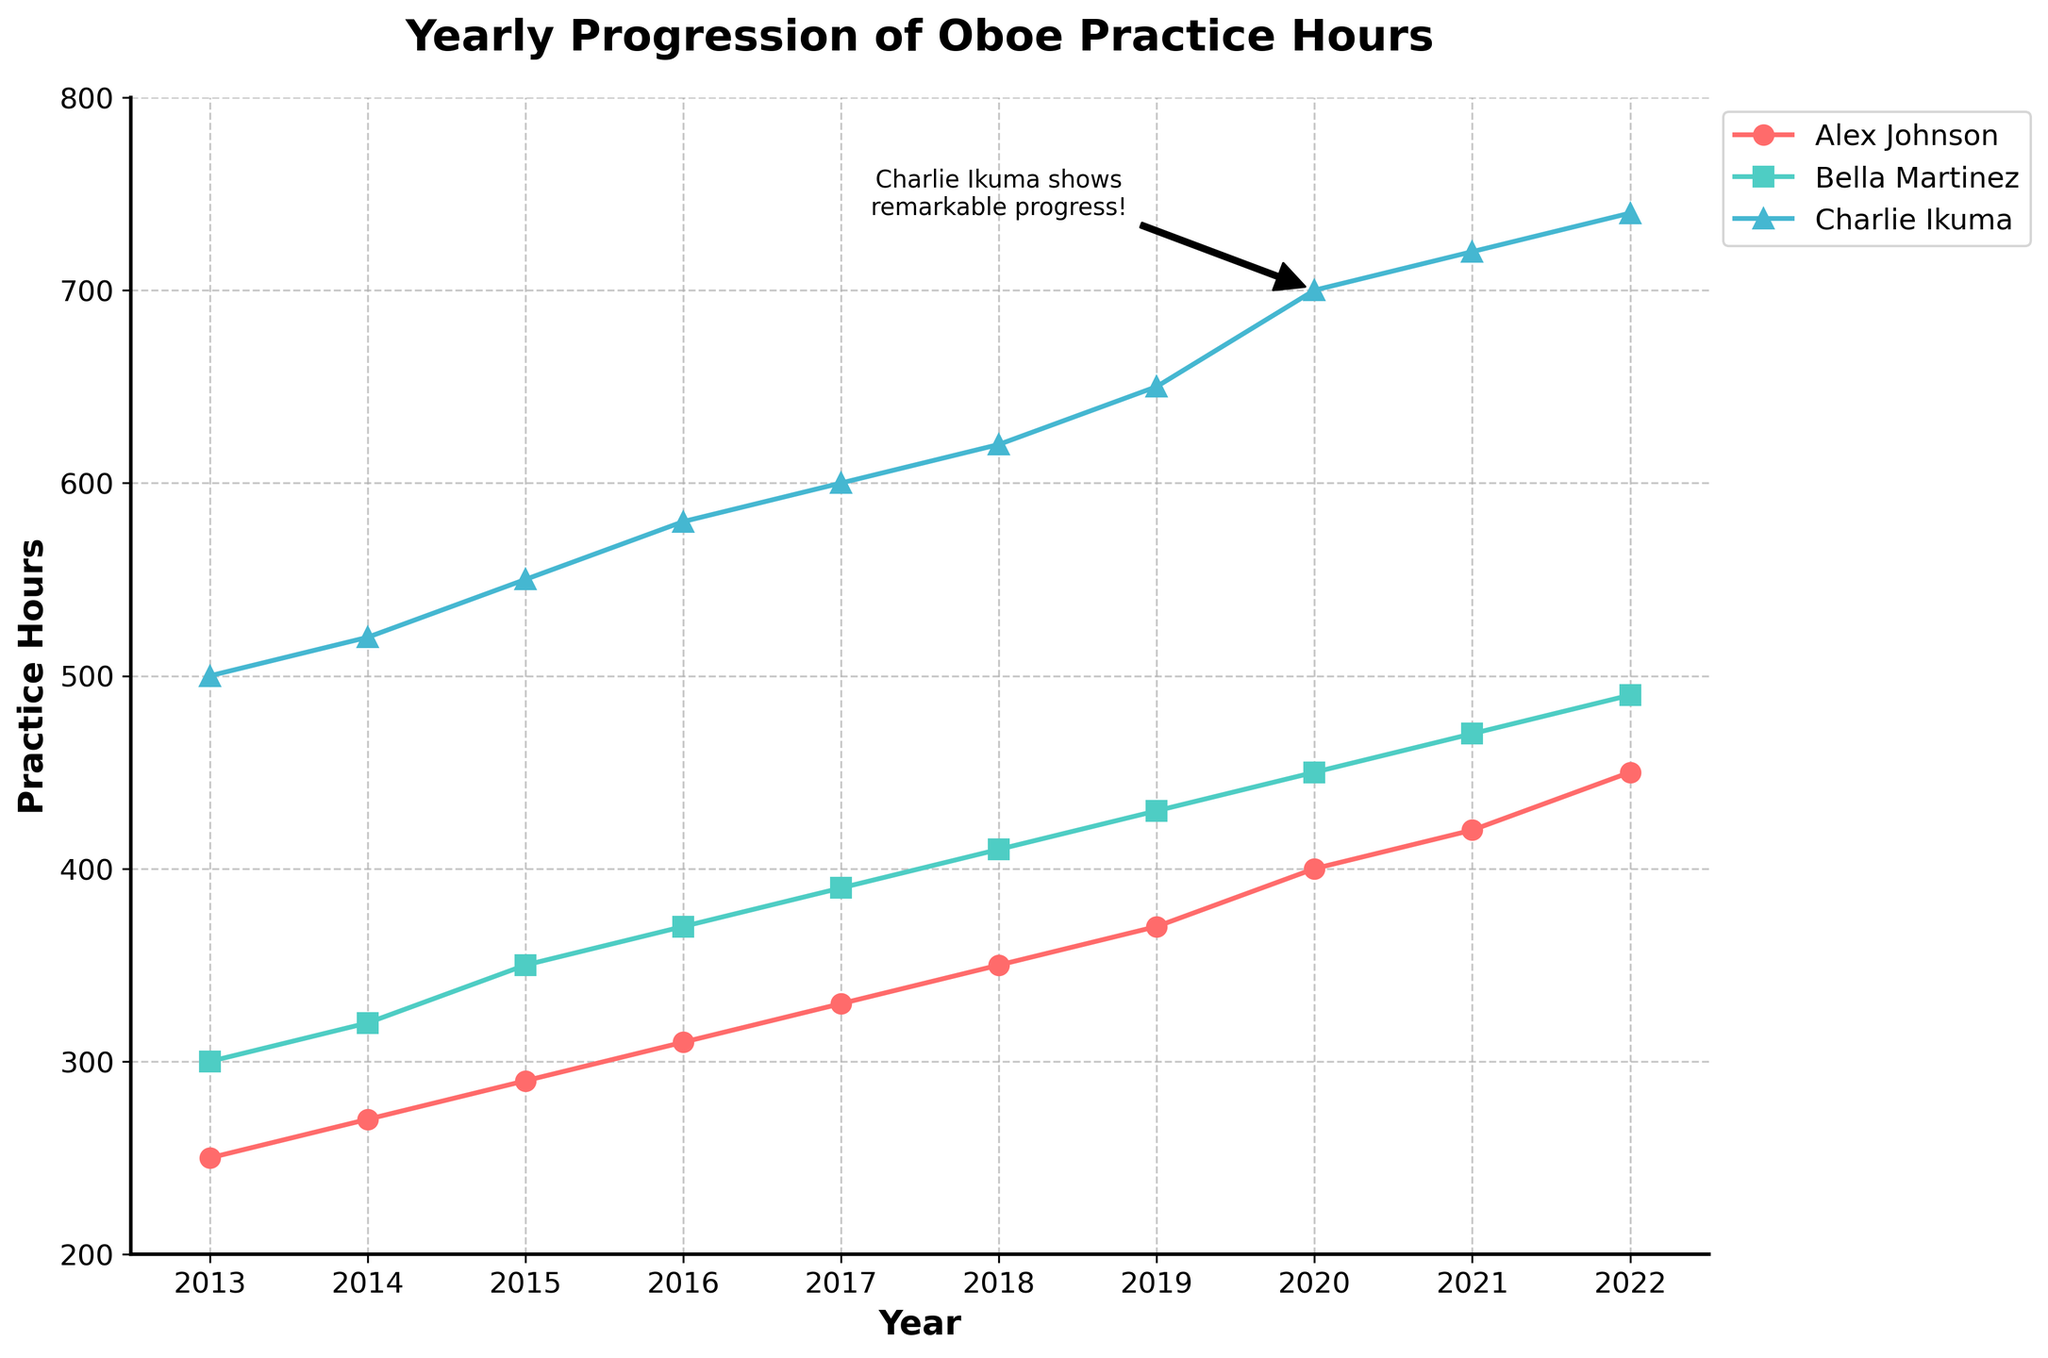What is the title of the figure? The title of the figure is written in a larger, bold font at the top of the plot. It reads "Yearly Progression of Oboe Practice Hours."
Answer: Yearly Progression of Oboe Practice Hours Which musician had the highest increase in practice hours over the 10 years? To find the highest increase, evaluate the difference between the practice hours in 2022 and 2013 for each musician. Charlie Ikuma increased from 500 hours in 2013 to 740 hours in 2022, which is an increase of 240 hours. This is higher compared to Alex Johnson's increase of 200 hours and Bella Martinez's increase of 190 hours.
Answer: Charlie Ikuma What is the average practice hours for Bella Martinez over the 10 years? To find the average practice hours for Bella Martinez, sum her practice hours from 2013 to 2022 and then divide by the number of years. The total is 300 + 320 + 350 + 370 + 390 + 410 + 430 + 450 + 470 + 490 = 3980. Dividing by the 10 years gives 398.
Answer: 398 In which year did Alex Johnson have the smallest increase in practice hours compared to the previous year? To find the year with the smallest increase, calculate the increase for each year from 2014 to 2022 by subtracting the practice hours of the previous year from the current year. 2014 - 2013: 20, 2015 - 2014: 20, 2016 - 2015: 20, 2017 - 2016: 20, 2018 - 2017: 20, 2019 - 2018: 20, 2020 - 2019: 30, 2021 - 2020: 20, 2022 - 2021: 30. All increases are 20 hours except for the years 2020-2019 and 2022-2021, which are 30. Hence any year besides 2019-2020 or 2021-2020 has the smallest increase.
Answer: 2014 or any other year from 2015 to 2019 How does Charlie Ikuma's practice hours in 2020 compare to Bella Martinez in the same year? Looking at the practice hours for 2020, Charlie Ikuma has 700 hours and Bella Martinez has 450 hours. Comparing these values shows that Charlie Ikuma practiced 250 more hours than Bella Martinez.
Answer: Charlie Ikuma practiced 250 hours more What is the trend in practice hours for Bella Martinez from 2013 to 2022? Observing the plot, Bella Martinez's practice hours show a steady increase from 300 hours in 2013 to 490 hours in 2022. This suggests a consistent upward trend in practice hours over the 10 years.
Answer: Steady increase What annotation is given in the figure and to whom does it refer? The annotation in the figure notes "Charlie Ikuma shows remarkable progress!" This points to the line representing Charlie Ikuma's practice hours, highlighting his significant improvement.
Answer: Charlie Ikuma Between which years did Alex Johnson have the largest increase in practice hours? To find the largest yearly increase for Alex Johnson, calculate the difference in practice hours for each consecutive year. The increase from 2019 to 2020 is the largest at 30 hours (from 370 to 400 hours).
Answer: 2019 to 2020 Which musician had the highest practice hours in 2022? Check the practice hours for each musician in 2022. Charlie Ikuma had 740 hours, Alex Johnson had 450 hours, and Bella Martinez had 490 hours. Therefore, Charlie Ikuma had the highest practice hours in 2022.
Answer: Charlie Ikuma Is there any visible pattern or correlation in the practice hours of the three musicians over the years? All three musicians show a positive trend in practice hours, with their hours increasing steadily each year, indicating a continuous commitment to practice.
Answer: Positive trend 